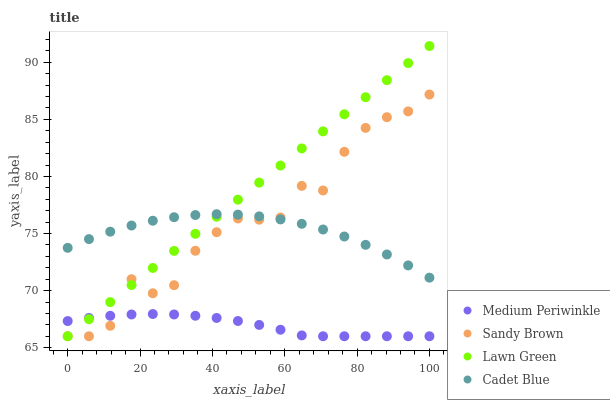Does Medium Periwinkle have the minimum area under the curve?
Answer yes or no. Yes. Does Lawn Green have the maximum area under the curve?
Answer yes or no. Yes. Does Cadet Blue have the minimum area under the curve?
Answer yes or no. No. Does Cadet Blue have the maximum area under the curve?
Answer yes or no. No. Is Lawn Green the smoothest?
Answer yes or no. Yes. Is Sandy Brown the roughest?
Answer yes or no. Yes. Is Cadet Blue the smoothest?
Answer yes or no. No. Is Cadet Blue the roughest?
Answer yes or no. No. Does Sandy Brown have the lowest value?
Answer yes or no. Yes. Does Cadet Blue have the lowest value?
Answer yes or no. No. Does Lawn Green have the highest value?
Answer yes or no. Yes. Does Cadet Blue have the highest value?
Answer yes or no. No. Is Medium Periwinkle less than Cadet Blue?
Answer yes or no. Yes. Is Cadet Blue greater than Medium Periwinkle?
Answer yes or no. Yes. Does Lawn Green intersect Cadet Blue?
Answer yes or no. Yes. Is Lawn Green less than Cadet Blue?
Answer yes or no. No. Is Lawn Green greater than Cadet Blue?
Answer yes or no. No. Does Medium Periwinkle intersect Cadet Blue?
Answer yes or no. No. 